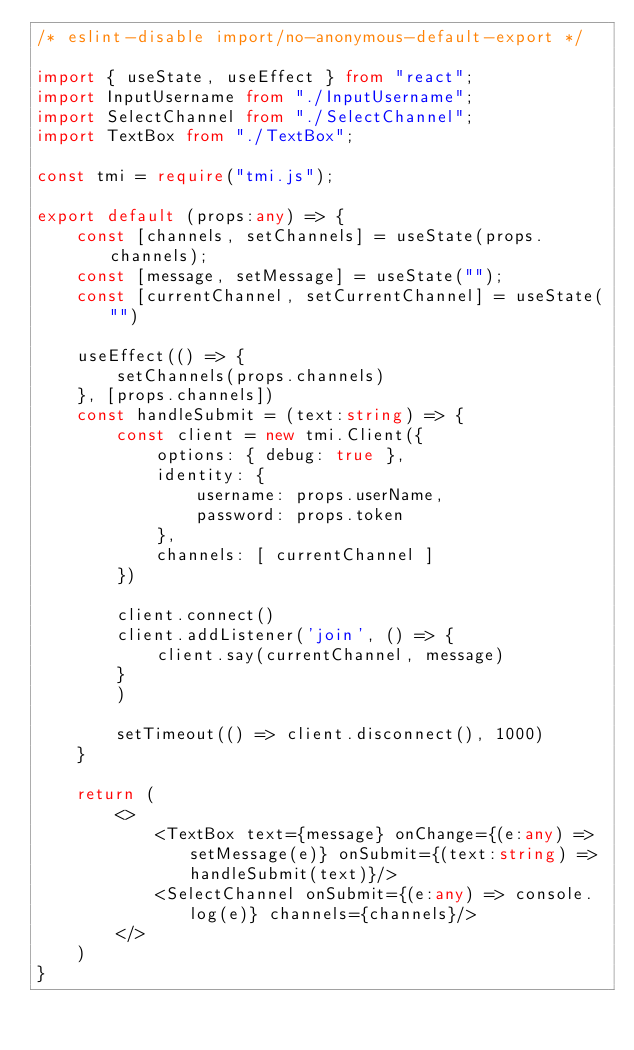<code> <loc_0><loc_0><loc_500><loc_500><_TypeScript_>/* eslint-disable import/no-anonymous-default-export */

import { useState, useEffect } from "react";
import InputUsername from "./InputUsername";
import SelectChannel from "./SelectChannel";
import TextBox from "./TextBox";

const tmi = require("tmi.js");

export default (props:any) => {
    const [channels, setChannels] = useState(props.channels);
    const [message, setMessage] = useState("");
    const [currentChannel, setCurrentChannel] = useState("")

    useEffect(() => {
        setChannels(props.channels)
    }, [props.channels])
    const handleSubmit = (text:string) => {
        const client = new tmi.Client({
            options: { debug: true },
            identity: {
                username: props.userName,
                password: props.token
            },
            channels: [ currentChannel ]
        })
        
        client.connect()
        client.addListener('join', () => {
            client.say(currentChannel, message)
        }
        )

        setTimeout(() => client.disconnect(), 1000)
    }

    return (
        <>
            <TextBox text={message} onChange={(e:any) => setMessage(e)} onSubmit={(text:string) => handleSubmit(text)}/>
            <SelectChannel onSubmit={(e:any) => console.log(e)} channels={channels}/>
        </>
    )
}</code> 